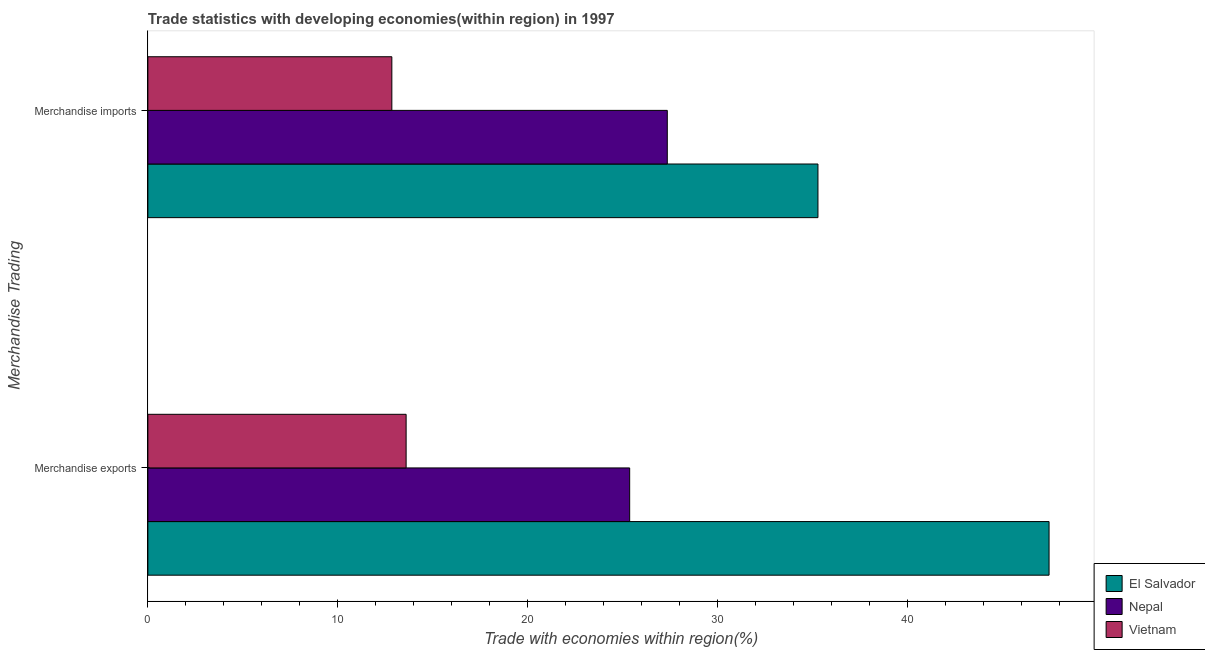How many groups of bars are there?
Offer a very short reply. 2. How many bars are there on the 2nd tick from the top?
Give a very brief answer. 3. What is the label of the 1st group of bars from the top?
Your answer should be compact. Merchandise imports. What is the merchandise imports in Vietnam?
Your answer should be compact. 12.85. Across all countries, what is the maximum merchandise exports?
Keep it short and to the point. 47.46. Across all countries, what is the minimum merchandise exports?
Provide a short and direct response. 13.6. In which country was the merchandise imports maximum?
Offer a terse response. El Salvador. In which country was the merchandise imports minimum?
Ensure brevity in your answer.  Vietnam. What is the total merchandise imports in the graph?
Ensure brevity in your answer.  75.49. What is the difference between the merchandise imports in Nepal and that in El Salvador?
Make the answer very short. -7.93. What is the difference between the merchandise imports in Vietnam and the merchandise exports in El Salvador?
Your answer should be compact. -34.61. What is the average merchandise imports per country?
Give a very brief answer. 25.16. What is the difference between the merchandise exports and merchandise imports in El Salvador?
Your answer should be very brief. 12.17. In how many countries, is the merchandise imports greater than 28 %?
Your answer should be very brief. 1. What is the ratio of the merchandise imports in El Salvador to that in Nepal?
Keep it short and to the point. 1.29. Is the merchandise exports in El Salvador less than that in Vietnam?
Ensure brevity in your answer.  No. What does the 3rd bar from the top in Merchandise exports represents?
Your answer should be very brief. El Salvador. What does the 3rd bar from the bottom in Merchandise imports represents?
Ensure brevity in your answer.  Vietnam. How many bars are there?
Make the answer very short. 6. Are all the bars in the graph horizontal?
Your response must be concise. Yes. How many countries are there in the graph?
Ensure brevity in your answer.  3. What is the difference between two consecutive major ticks on the X-axis?
Your answer should be compact. 10. Does the graph contain grids?
Keep it short and to the point. No. Where does the legend appear in the graph?
Provide a succinct answer. Bottom right. What is the title of the graph?
Give a very brief answer. Trade statistics with developing economies(within region) in 1997. Does "Latin America(all income levels)" appear as one of the legend labels in the graph?
Ensure brevity in your answer.  No. What is the label or title of the X-axis?
Keep it short and to the point. Trade with economies within region(%). What is the label or title of the Y-axis?
Your answer should be very brief. Merchandise Trading. What is the Trade with economies within region(%) in El Salvador in Merchandise exports?
Make the answer very short. 47.46. What is the Trade with economies within region(%) of Nepal in Merchandise exports?
Offer a very short reply. 25.37. What is the Trade with economies within region(%) in Vietnam in Merchandise exports?
Offer a very short reply. 13.6. What is the Trade with economies within region(%) in El Salvador in Merchandise imports?
Your answer should be compact. 35.29. What is the Trade with economies within region(%) of Nepal in Merchandise imports?
Offer a very short reply. 27.35. What is the Trade with economies within region(%) of Vietnam in Merchandise imports?
Give a very brief answer. 12.85. Across all Merchandise Trading, what is the maximum Trade with economies within region(%) in El Salvador?
Offer a very short reply. 47.46. Across all Merchandise Trading, what is the maximum Trade with economies within region(%) of Nepal?
Your answer should be compact. 27.35. Across all Merchandise Trading, what is the maximum Trade with economies within region(%) of Vietnam?
Provide a short and direct response. 13.6. Across all Merchandise Trading, what is the minimum Trade with economies within region(%) in El Salvador?
Your response must be concise. 35.29. Across all Merchandise Trading, what is the minimum Trade with economies within region(%) of Nepal?
Provide a succinct answer. 25.37. Across all Merchandise Trading, what is the minimum Trade with economies within region(%) of Vietnam?
Provide a short and direct response. 12.85. What is the total Trade with economies within region(%) of El Salvador in the graph?
Provide a succinct answer. 82.74. What is the total Trade with economies within region(%) in Nepal in the graph?
Offer a terse response. 52.72. What is the total Trade with economies within region(%) in Vietnam in the graph?
Make the answer very short. 26.45. What is the difference between the Trade with economies within region(%) in El Salvador in Merchandise exports and that in Merchandise imports?
Provide a succinct answer. 12.17. What is the difference between the Trade with economies within region(%) of Nepal in Merchandise exports and that in Merchandise imports?
Keep it short and to the point. -1.98. What is the difference between the Trade with economies within region(%) in Vietnam in Merchandise exports and that in Merchandise imports?
Ensure brevity in your answer.  0.75. What is the difference between the Trade with economies within region(%) of El Salvador in Merchandise exports and the Trade with economies within region(%) of Nepal in Merchandise imports?
Give a very brief answer. 20.1. What is the difference between the Trade with economies within region(%) in El Salvador in Merchandise exports and the Trade with economies within region(%) in Vietnam in Merchandise imports?
Make the answer very short. 34.61. What is the difference between the Trade with economies within region(%) in Nepal in Merchandise exports and the Trade with economies within region(%) in Vietnam in Merchandise imports?
Give a very brief answer. 12.52. What is the average Trade with economies within region(%) of El Salvador per Merchandise Trading?
Your answer should be very brief. 41.37. What is the average Trade with economies within region(%) of Nepal per Merchandise Trading?
Keep it short and to the point. 26.36. What is the average Trade with economies within region(%) of Vietnam per Merchandise Trading?
Keep it short and to the point. 13.22. What is the difference between the Trade with economies within region(%) in El Salvador and Trade with economies within region(%) in Nepal in Merchandise exports?
Ensure brevity in your answer.  22.09. What is the difference between the Trade with economies within region(%) of El Salvador and Trade with economies within region(%) of Vietnam in Merchandise exports?
Make the answer very short. 33.86. What is the difference between the Trade with economies within region(%) in Nepal and Trade with economies within region(%) in Vietnam in Merchandise exports?
Your response must be concise. 11.77. What is the difference between the Trade with economies within region(%) in El Salvador and Trade with economies within region(%) in Nepal in Merchandise imports?
Provide a succinct answer. 7.93. What is the difference between the Trade with economies within region(%) of El Salvador and Trade with economies within region(%) of Vietnam in Merchandise imports?
Keep it short and to the point. 22.44. What is the difference between the Trade with economies within region(%) of Nepal and Trade with economies within region(%) of Vietnam in Merchandise imports?
Your answer should be compact. 14.51. What is the ratio of the Trade with economies within region(%) in El Salvador in Merchandise exports to that in Merchandise imports?
Your answer should be compact. 1.34. What is the ratio of the Trade with economies within region(%) in Nepal in Merchandise exports to that in Merchandise imports?
Keep it short and to the point. 0.93. What is the ratio of the Trade with economies within region(%) in Vietnam in Merchandise exports to that in Merchandise imports?
Your response must be concise. 1.06. What is the difference between the highest and the second highest Trade with economies within region(%) of El Salvador?
Make the answer very short. 12.17. What is the difference between the highest and the second highest Trade with economies within region(%) of Nepal?
Provide a succinct answer. 1.98. What is the difference between the highest and the second highest Trade with economies within region(%) of Vietnam?
Keep it short and to the point. 0.75. What is the difference between the highest and the lowest Trade with economies within region(%) of El Salvador?
Give a very brief answer. 12.17. What is the difference between the highest and the lowest Trade with economies within region(%) in Nepal?
Your answer should be very brief. 1.98. What is the difference between the highest and the lowest Trade with economies within region(%) of Vietnam?
Offer a very short reply. 0.75. 